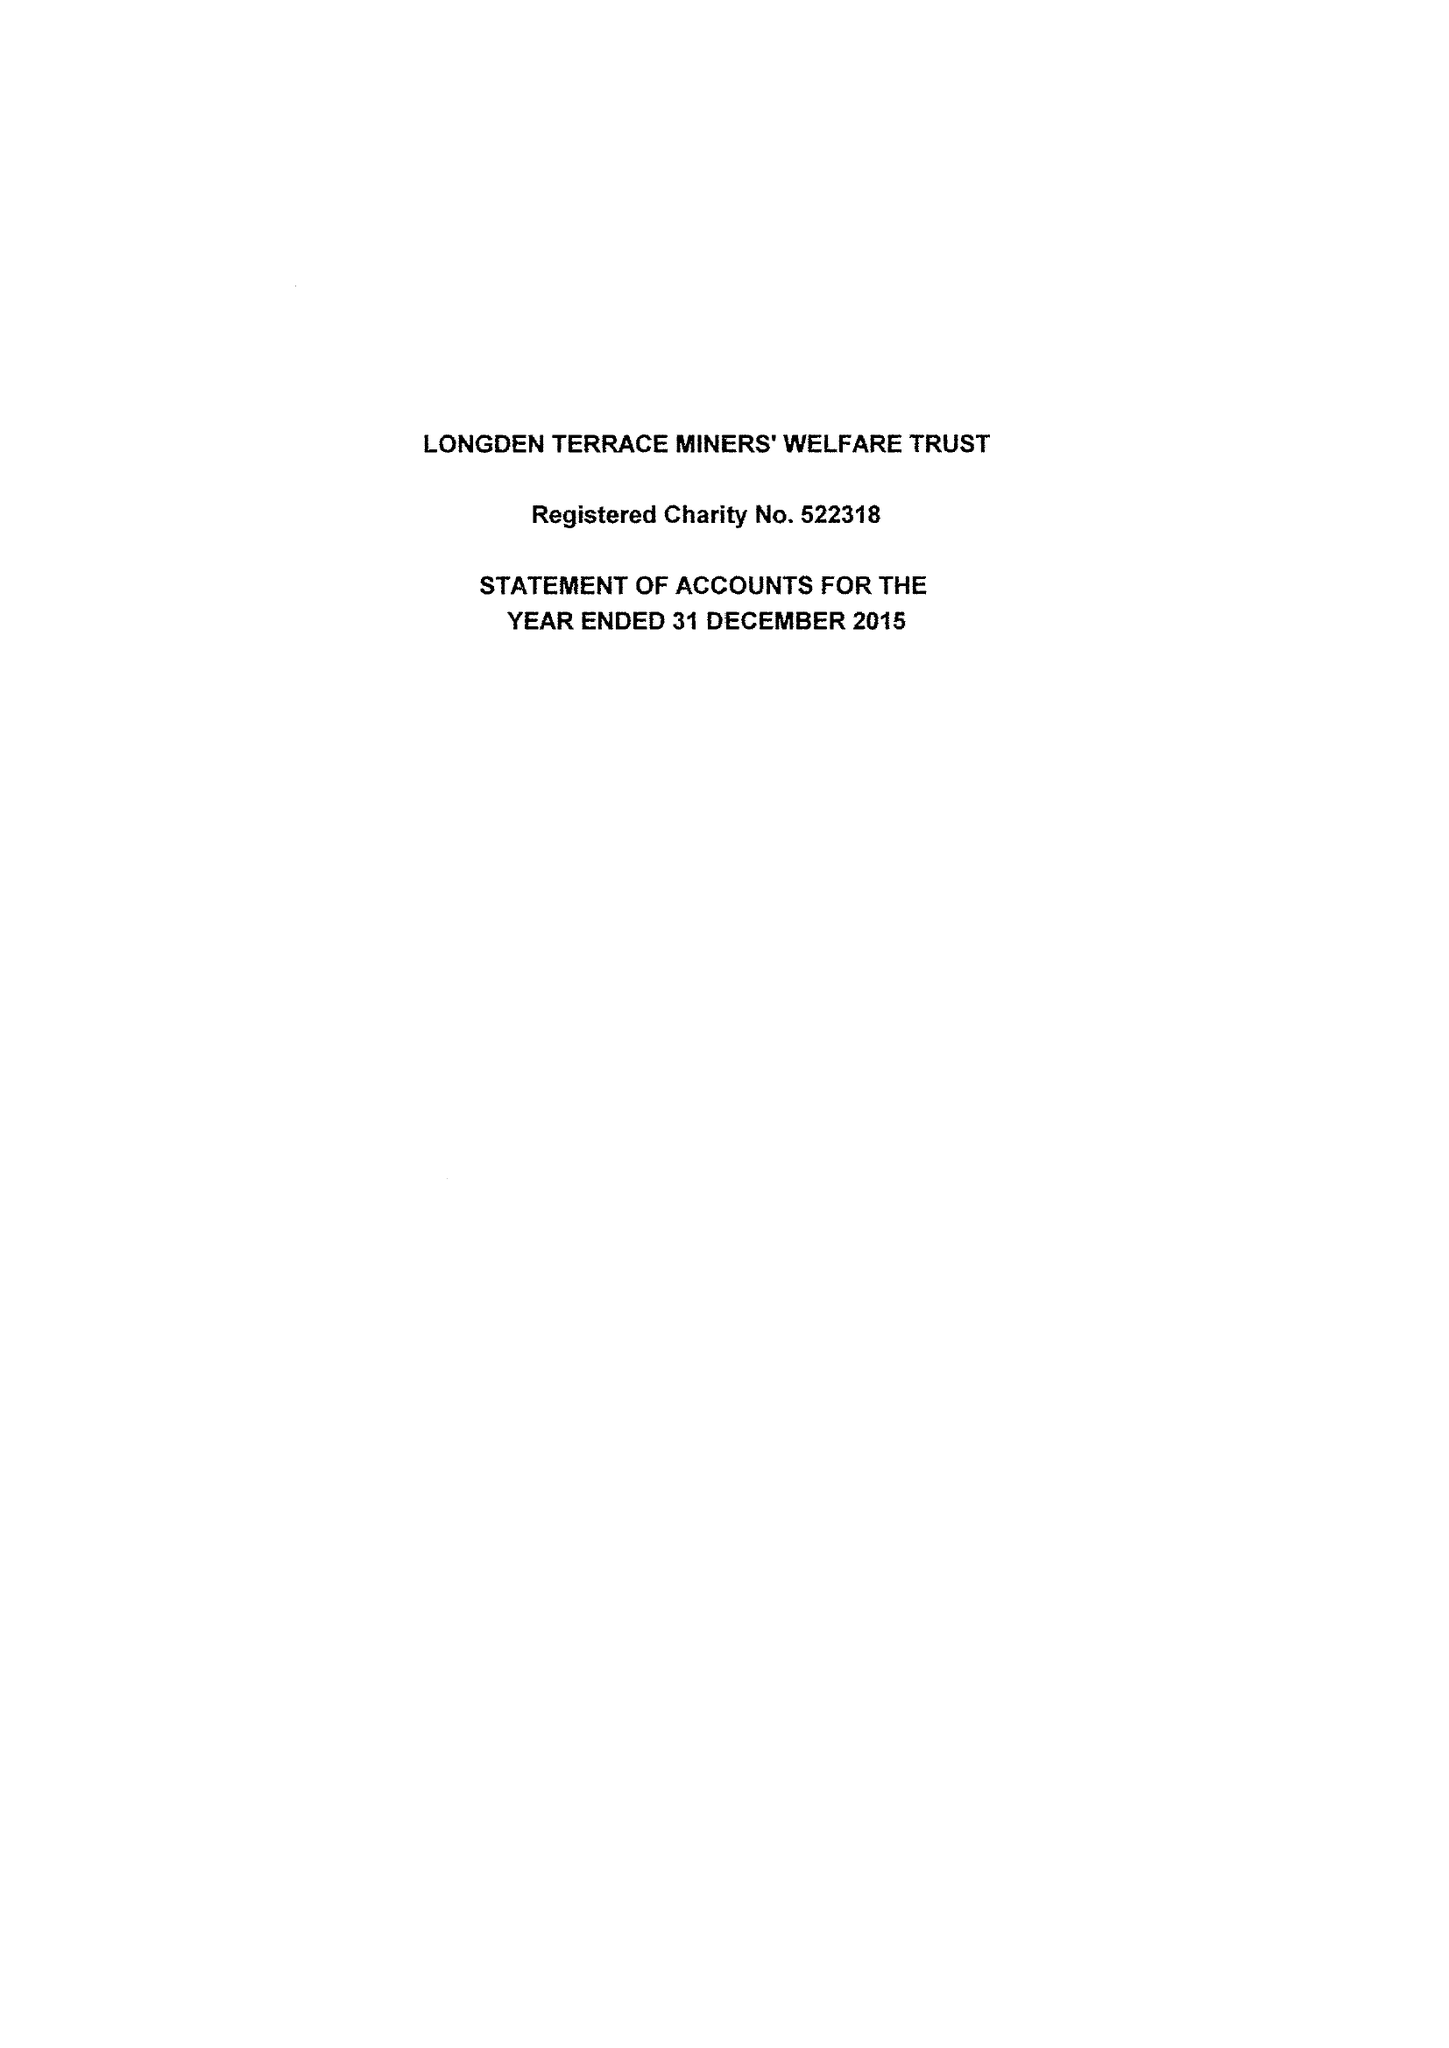What is the value for the report_date?
Answer the question using a single word or phrase. 2015-12-31 